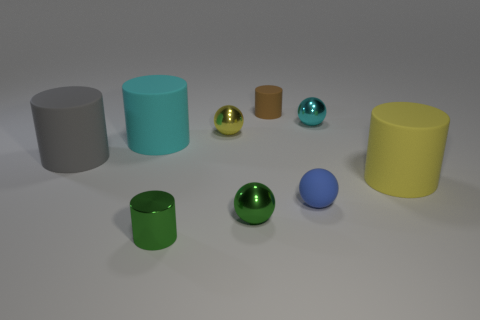Subtract all small blue spheres. How many spheres are left? 3 Subtract 1 balls. How many balls are left? 3 Subtract all green spheres. How many spheres are left? 3 Subtract all cylinders. How many objects are left? 4 Subtract all purple cylinders. Subtract all blue blocks. How many cylinders are left? 5 Subtract all brown metallic cylinders. Subtract all matte things. How many objects are left? 4 Add 1 gray cylinders. How many gray cylinders are left? 2 Add 1 tiny brown rubber balls. How many tiny brown rubber balls exist? 1 Subtract 0 brown blocks. How many objects are left? 9 